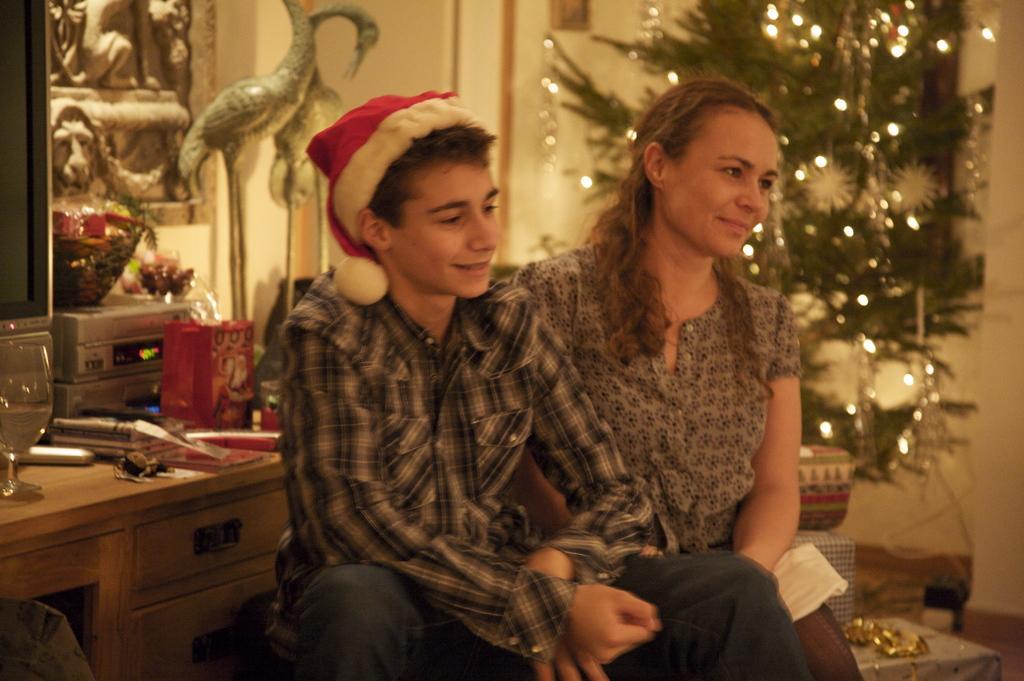Describe this image in one or two sentences. There is a man and woman here and man is wearing cap on his head. Behind them there is a table,TV,wall,sculptures,Christmas tree. 